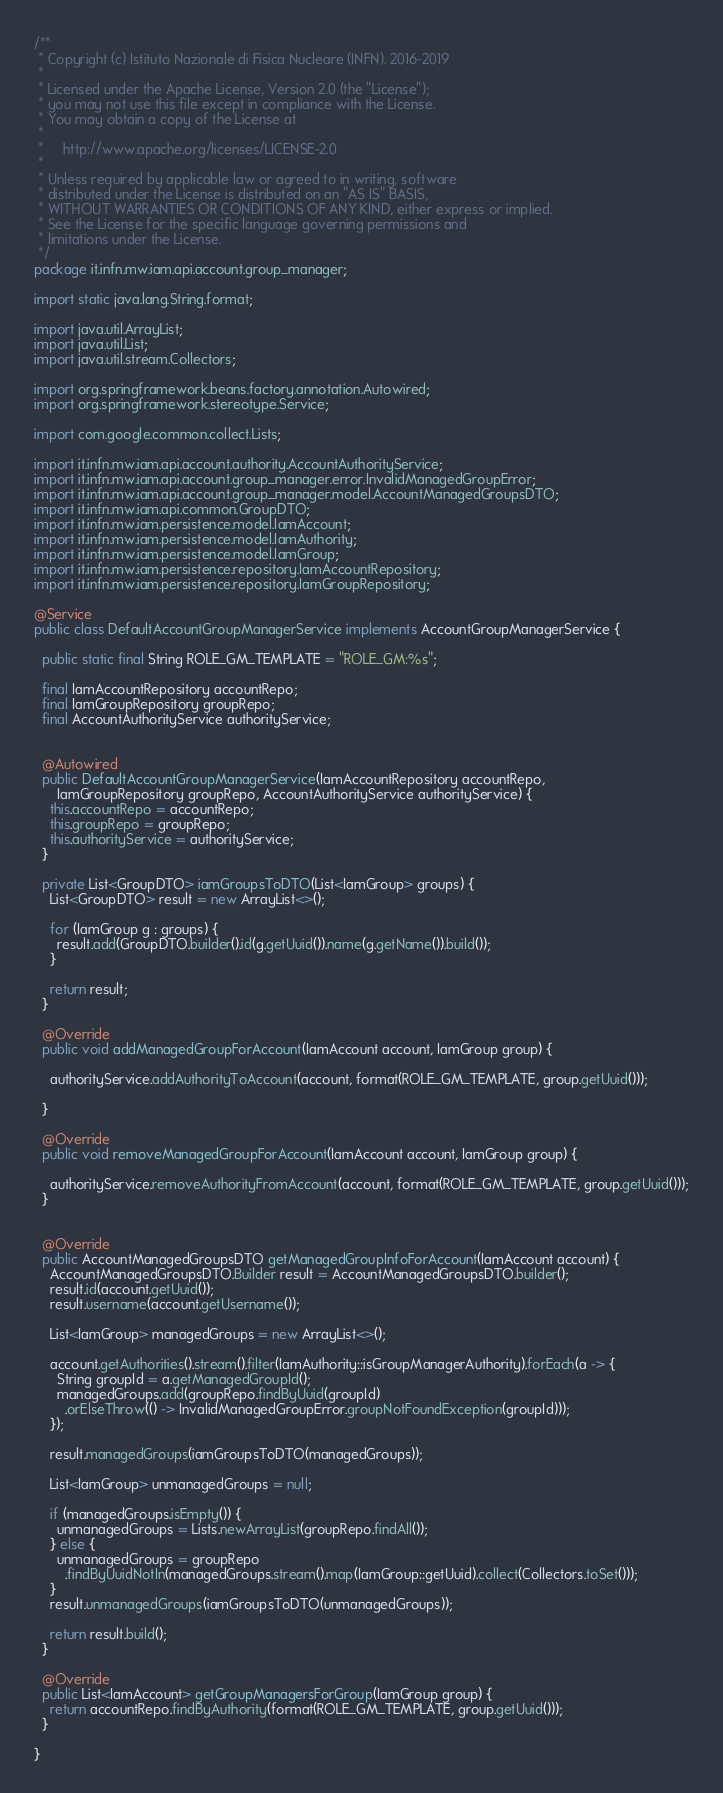<code> <loc_0><loc_0><loc_500><loc_500><_Java_>/**
 * Copyright (c) Istituto Nazionale di Fisica Nucleare (INFN). 2016-2019
 *
 * Licensed under the Apache License, Version 2.0 (the "License");
 * you may not use this file except in compliance with the License.
 * You may obtain a copy of the License at
 *
 *     http://www.apache.org/licenses/LICENSE-2.0
 *
 * Unless required by applicable law or agreed to in writing, software
 * distributed under the License is distributed on an "AS IS" BASIS,
 * WITHOUT WARRANTIES OR CONDITIONS OF ANY KIND, either express or implied.
 * See the License for the specific language governing permissions and
 * limitations under the License.
 */
package it.infn.mw.iam.api.account.group_manager;

import static java.lang.String.format;

import java.util.ArrayList;
import java.util.List;
import java.util.stream.Collectors;

import org.springframework.beans.factory.annotation.Autowired;
import org.springframework.stereotype.Service;

import com.google.common.collect.Lists;

import it.infn.mw.iam.api.account.authority.AccountAuthorityService;
import it.infn.mw.iam.api.account.group_manager.error.InvalidManagedGroupError;
import it.infn.mw.iam.api.account.group_manager.model.AccountManagedGroupsDTO;
import it.infn.mw.iam.api.common.GroupDTO;
import it.infn.mw.iam.persistence.model.IamAccount;
import it.infn.mw.iam.persistence.model.IamAuthority;
import it.infn.mw.iam.persistence.model.IamGroup;
import it.infn.mw.iam.persistence.repository.IamAccountRepository;
import it.infn.mw.iam.persistence.repository.IamGroupRepository;

@Service
public class DefaultAccountGroupManagerService implements AccountGroupManagerService {

  public static final String ROLE_GM_TEMPLATE = "ROLE_GM:%s";
  
  final IamAccountRepository accountRepo;
  final IamGroupRepository groupRepo;
  final AccountAuthorityService authorityService;


  @Autowired
  public DefaultAccountGroupManagerService(IamAccountRepository accountRepo,
      IamGroupRepository groupRepo, AccountAuthorityService authorityService) {
    this.accountRepo = accountRepo;
    this.groupRepo = groupRepo;
    this.authorityService = authorityService;
  }

  private List<GroupDTO> iamGroupsToDTO(List<IamGroup> groups) {
    List<GroupDTO> result = new ArrayList<>();

    for (IamGroup g : groups) {
      result.add(GroupDTO.builder().id(g.getUuid()).name(g.getName()).build());
    }

    return result;
  }

  @Override
  public void addManagedGroupForAccount(IamAccount account, IamGroup group) {

    authorityService.addAuthorityToAccount(account, format(ROLE_GM_TEMPLATE, group.getUuid()));

  }

  @Override
  public void removeManagedGroupForAccount(IamAccount account, IamGroup group) {

    authorityService.removeAuthorityFromAccount(account, format(ROLE_GM_TEMPLATE, group.getUuid()));
  }


  @Override
  public AccountManagedGroupsDTO getManagedGroupInfoForAccount(IamAccount account) {
    AccountManagedGroupsDTO.Builder result = AccountManagedGroupsDTO.builder();
    result.id(account.getUuid());
    result.username(account.getUsername());

    List<IamGroup> managedGroups = new ArrayList<>();

    account.getAuthorities().stream().filter(IamAuthority::isGroupManagerAuthority).forEach(a -> {
      String groupId = a.getManagedGroupId();
      managedGroups.add(groupRepo.findByUuid(groupId)
        .orElseThrow(() -> InvalidManagedGroupError.groupNotFoundException(groupId)));
    });

    result.managedGroups(iamGroupsToDTO(managedGroups));

    List<IamGroup> unmanagedGroups = null;

    if (managedGroups.isEmpty()) {
      unmanagedGroups = Lists.newArrayList(groupRepo.findAll());
    } else {
      unmanagedGroups = groupRepo
        .findByUuidNotIn(managedGroups.stream().map(IamGroup::getUuid).collect(Collectors.toSet()));
    }
    result.unmanagedGroups(iamGroupsToDTO(unmanagedGroups));

    return result.build();
  }

  @Override
  public List<IamAccount> getGroupManagersForGroup(IamGroup group) {
    return accountRepo.findByAuthority(format(ROLE_GM_TEMPLATE, group.getUuid()));
  }

}
</code> 